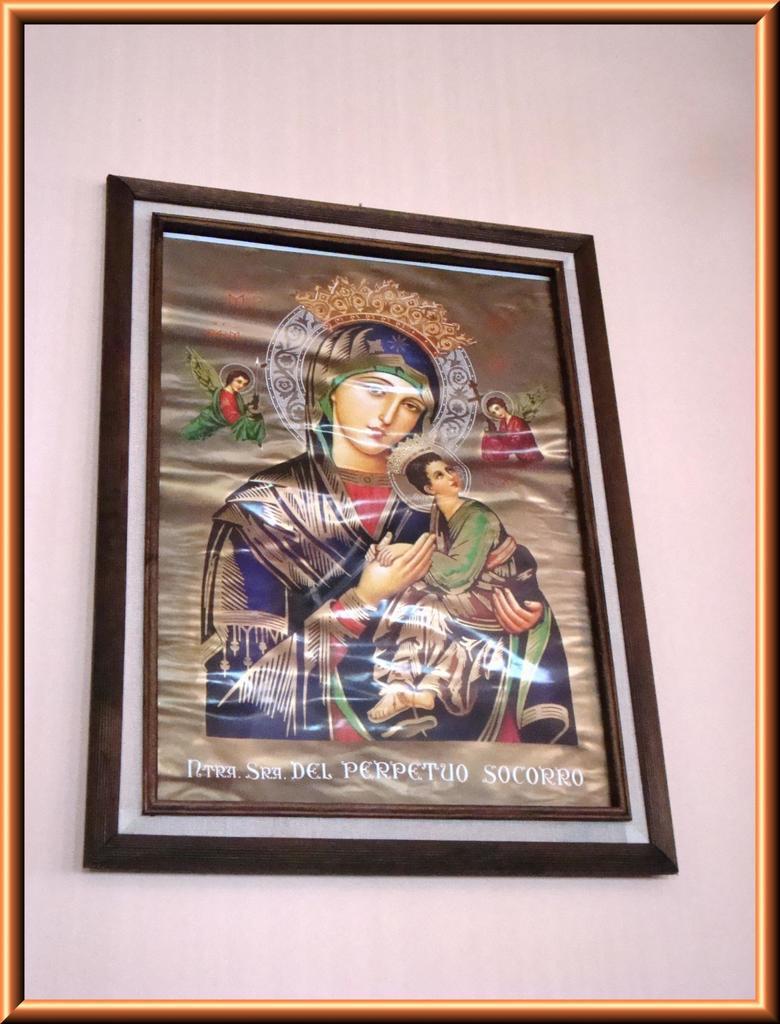Describe this image in one or two sentences. In this picture we can see a wall, there is a photo frame on the wall, we can see some text here. 